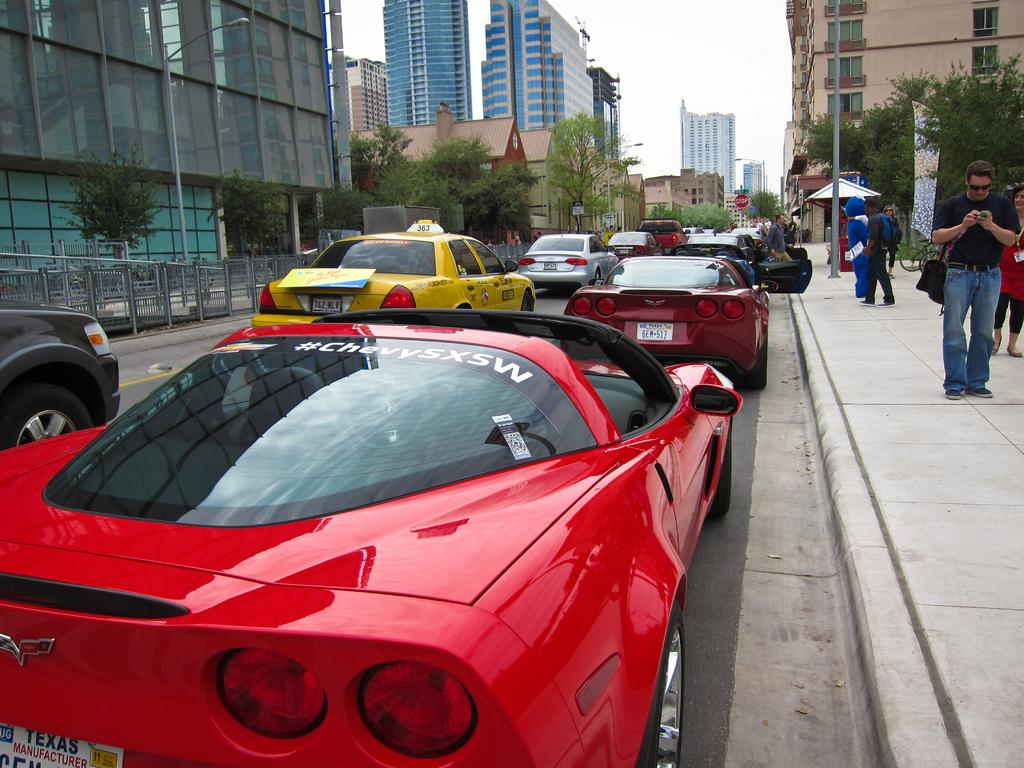<image>
Give a short and clear explanation of the subsequent image. a red car that says Chevy on it 